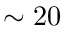Convert formula to latex. <formula><loc_0><loc_0><loc_500><loc_500>\sim 2 0</formula> 